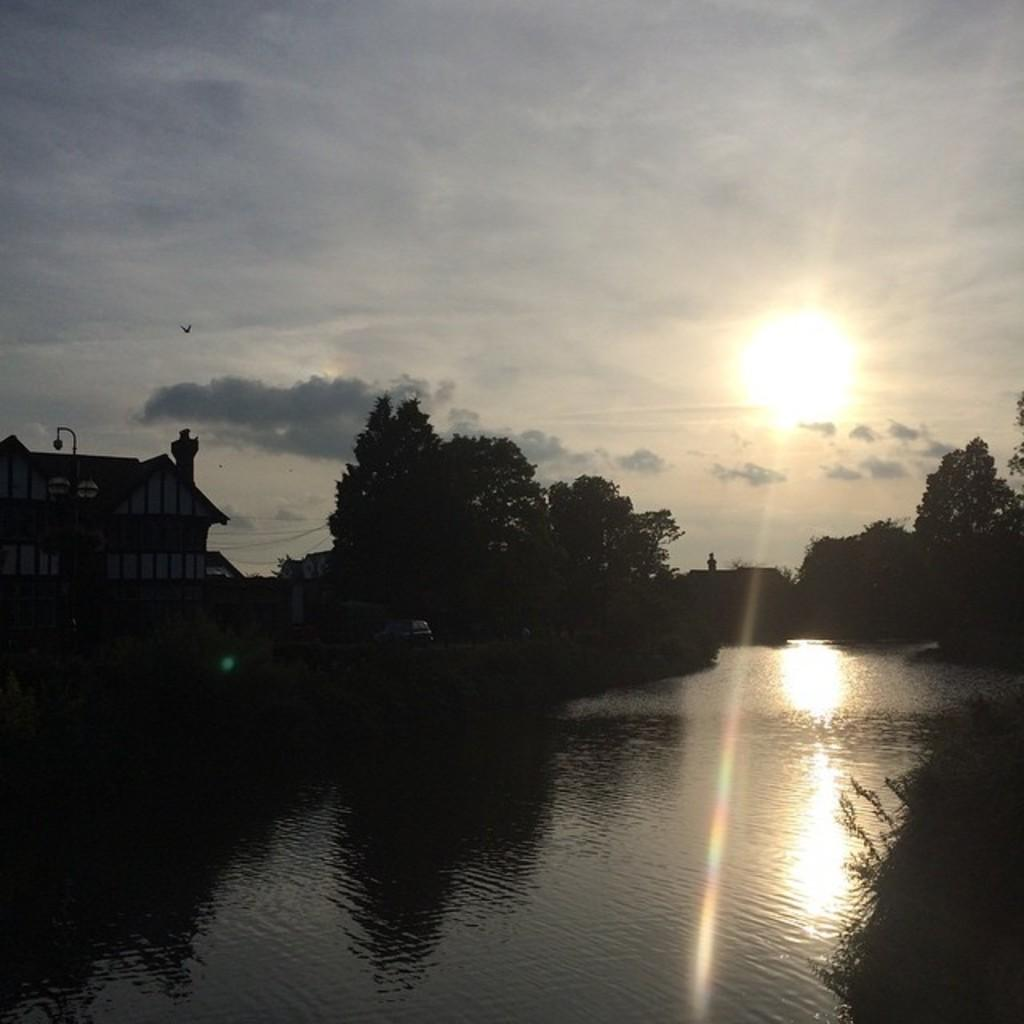What type of vegetation can be seen in the image? There are trees in the image. What natural element is visible in the image? There is water visible in the image. What type of man-made structures are present in the image? There are buildings in the image. Can you describe the bird in the image? A bird is flying in the air in the background of the image. What is visible in the sky in the image? The sky is visible in the background of the image, and the sun is observable in the sky. What type of hair can be seen on the bird in the image? There is no bird with hair present in the image; the bird has feathers. What type of tax is being collected from the buildings in the image? There is no indication of tax collection in the image; it only shows buildings, trees, water, and a bird. 